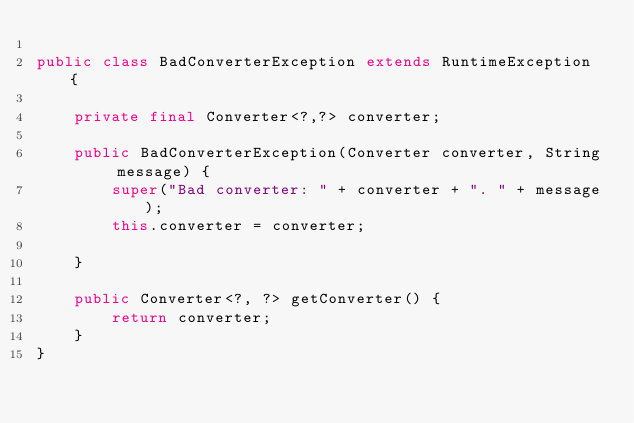Convert code to text. <code><loc_0><loc_0><loc_500><loc_500><_Java_>
public class BadConverterException extends RuntimeException {

    private final Converter<?,?> converter;

    public BadConverterException(Converter converter, String message) {
        super("Bad converter: " + converter + ". " + message);
        this.converter = converter;

    }

    public Converter<?, ?> getConverter() {
        return converter;
    }
}
</code> 